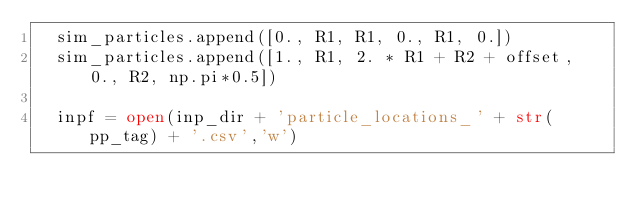<code> <loc_0><loc_0><loc_500><loc_500><_Python_>  sim_particles.append([0., R1, R1, 0., R1, 0.])
  sim_particles.append([1., R1, 2. * R1 + R2 + offset, 0., R2, np.pi*0.5])

  inpf = open(inp_dir + 'particle_locations_' + str(pp_tag) + '.csv','w')</code> 